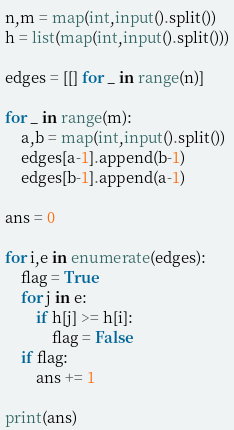<code> <loc_0><loc_0><loc_500><loc_500><_Python_>n,m = map(int,input().split())
h = list(map(int,input().split()))

edges = [[] for _ in range(n)]

for _ in range(m):
    a,b = map(int,input().split())
    edges[a-1].append(b-1)
    edges[b-1].append(a-1)

ans = 0

for i,e in enumerate(edges):
    flag = True
    for j in e:
        if h[j] >= h[i]:
            flag = False
    if flag:
        ans += 1

print(ans)
</code> 